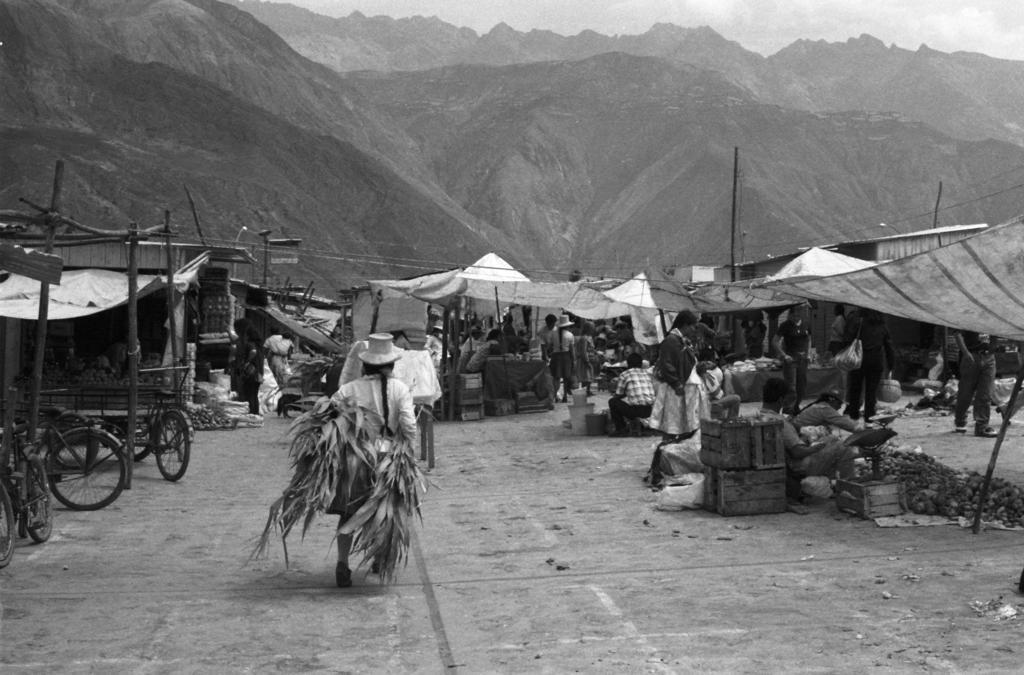How would you summarize this image in a sentence or two? This is a black and white image. In the image, there are many stoles with roofs and poles. And there are vegetables, wooden boxes and some other things. On the left side of the image there are bicycles. And there are few people in the image. In the background there are mountains. At the top of the image there is sky with clouds. 